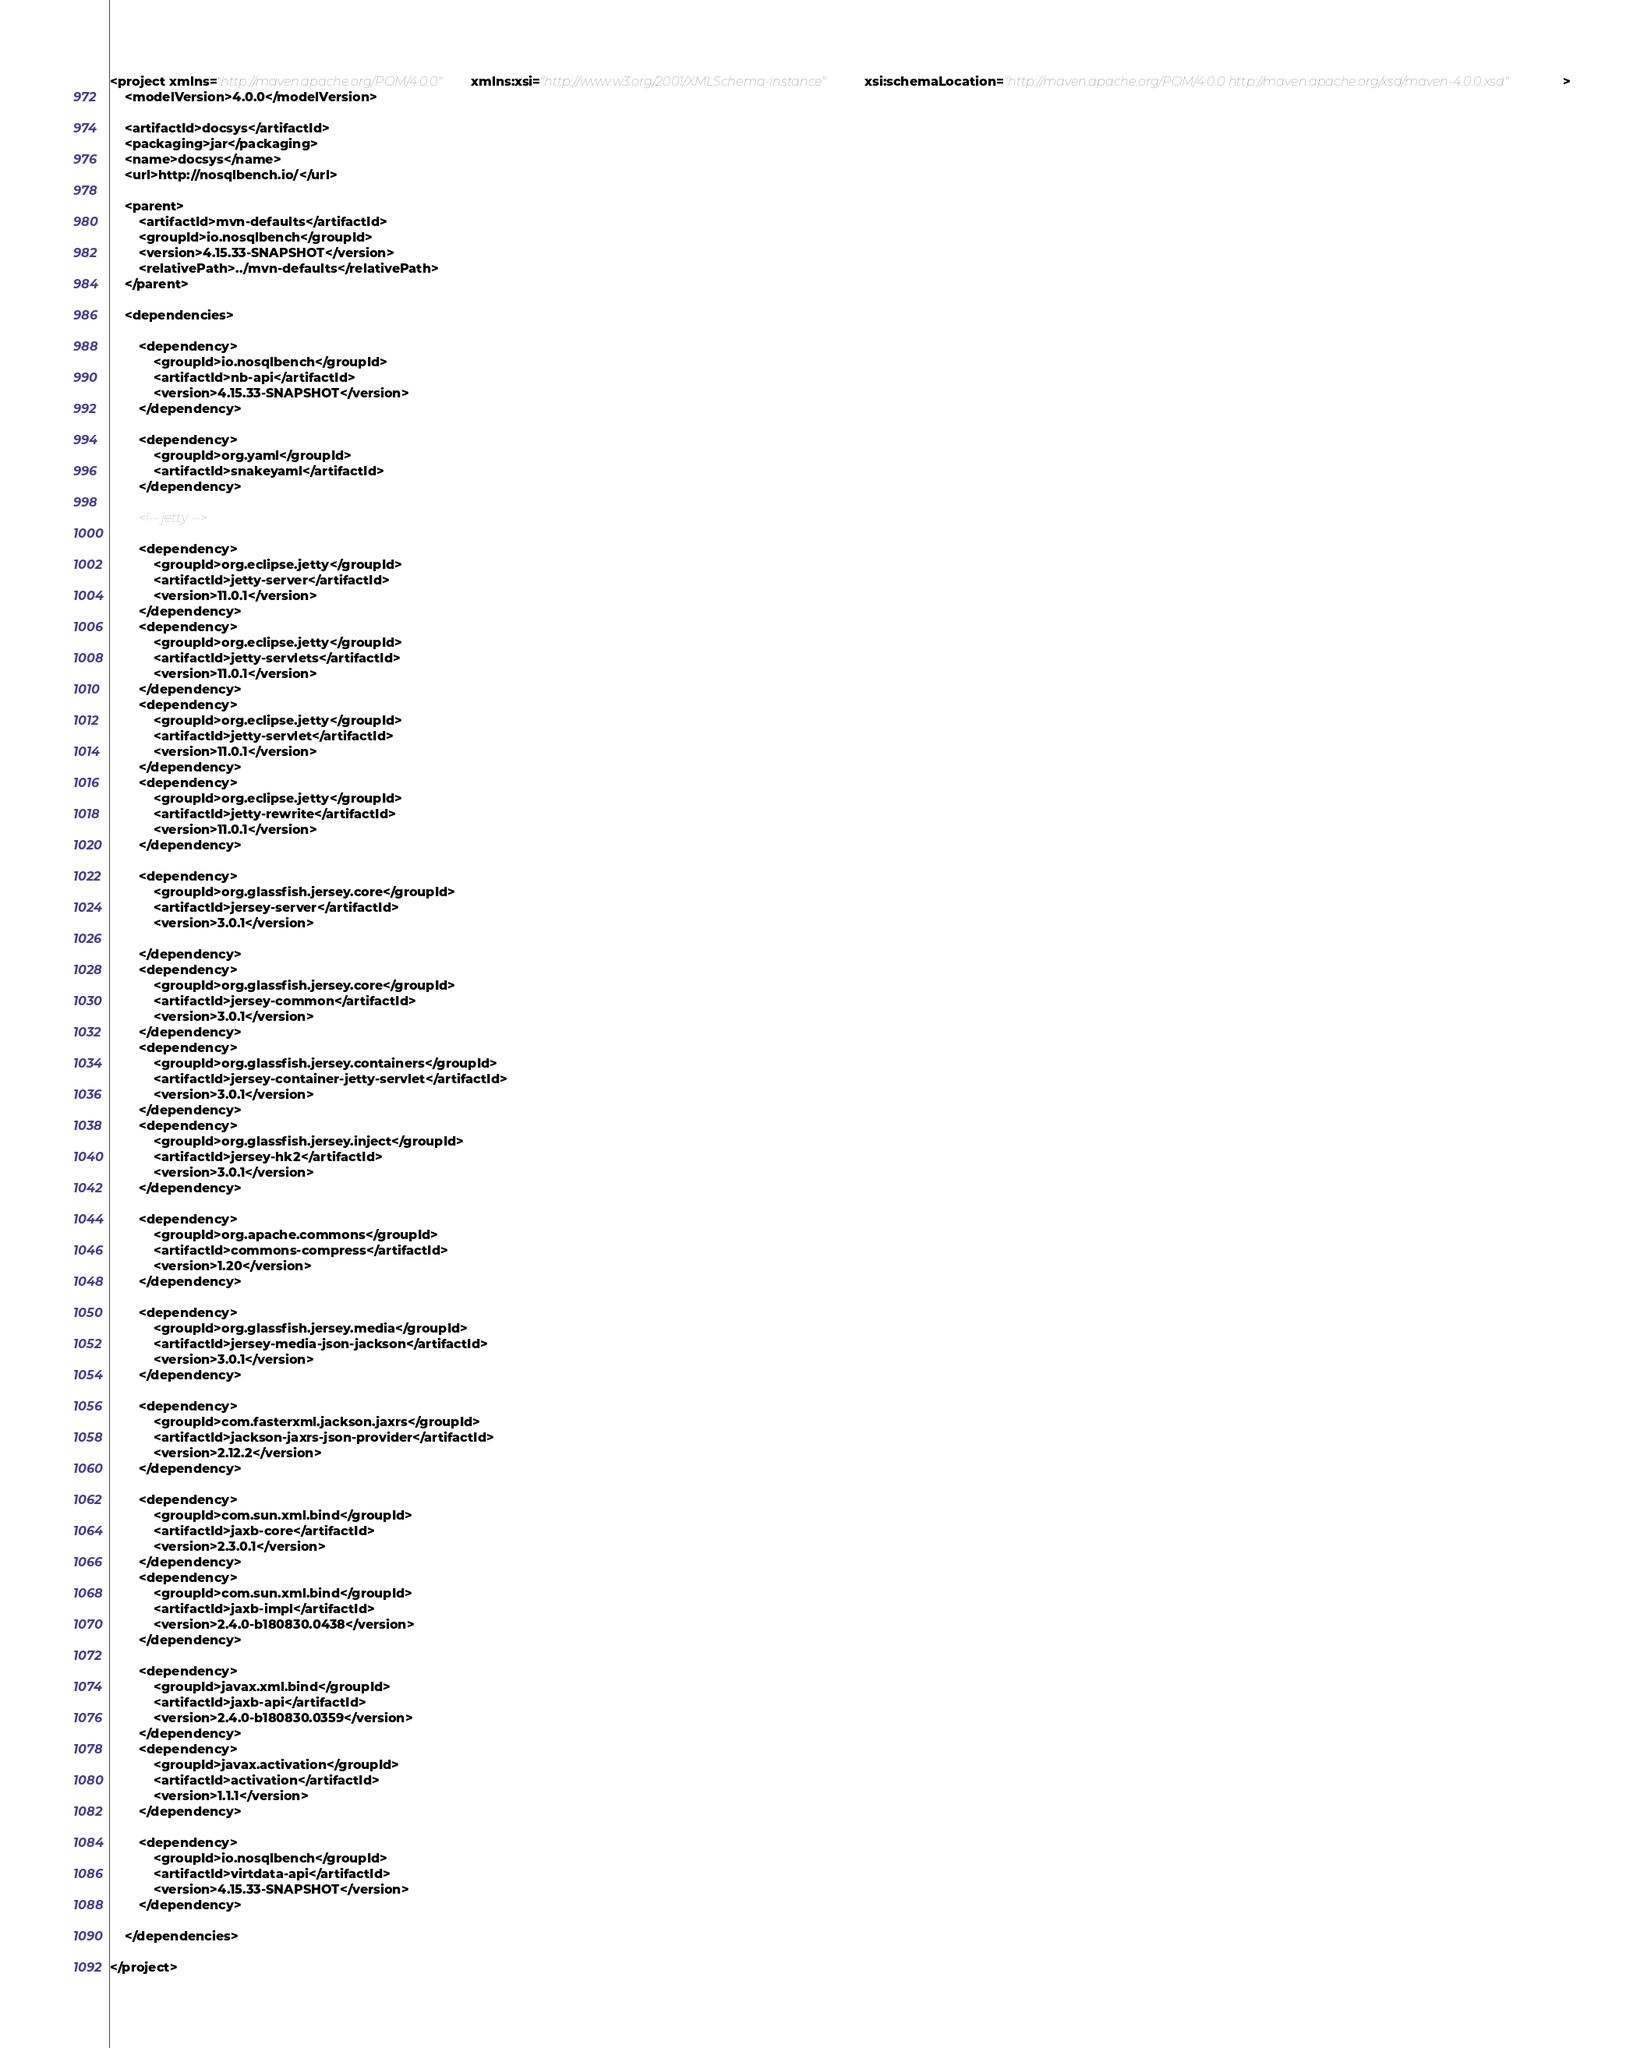Convert code to text. <code><loc_0><loc_0><loc_500><loc_500><_XML_><project xmlns="http://maven.apache.org/POM/4.0.0" xmlns:xsi="http://www.w3.org/2001/XMLSchema-instance" xsi:schemaLocation="http://maven.apache.org/POM/4.0.0 http://maven.apache.org/xsd/maven-4.0.0.xsd">
    <modelVersion>4.0.0</modelVersion>

    <artifactId>docsys</artifactId>
    <packaging>jar</packaging>
    <name>docsys</name>
    <url>http://nosqlbench.io/</url>

    <parent>
        <artifactId>mvn-defaults</artifactId>
        <groupId>io.nosqlbench</groupId>
        <version>4.15.33-SNAPSHOT</version>
        <relativePath>../mvn-defaults</relativePath>
    </parent>

    <dependencies>

        <dependency>
            <groupId>io.nosqlbench</groupId>
            <artifactId>nb-api</artifactId>
            <version>4.15.33-SNAPSHOT</version>
        </dependency>

        <dependency>
            <groupId>org.yaml</groupId>
            <artifactId>snakeyaml</artifactId>
        </dependency>

        <!-- jetty -->

        <dependency>
            <groupId>org.eclipse.jetty</groupId>
            <artifactId>jetty-server</artifactId>
            <version>11.0.1</version>
        </dependency>
        <dependency>
            <groupId>org.eclipse.jetty</groupId>
            <artifactId>jetty-servlets</artifactId>
            <version>11.0.1</version>
        </dependency>
        <dependency>
            <groupId>org.eclipse.jetty</groupId>
            <artifactId>jetty-servlet</artifactId>
            <version>11.0.1</version>
        </dependency>
        <dependency>
            <groupId>org.eclipse.jetty</groupId>
            <artifactId>jetty-rewrite</artifactId>
            <version>11.0.1</version>
        </dependency>

        <dependency>
            <groupId>org.glassfish.jersey.core</groupId>
            <artifactId>jersey-server</artifactId>
            <version>3.0.1</version>

        </dependency>
        <dependency>
            <groupId>org.glassfish.jersey.core</groupId>
            <artifactId>jersey-common</artifactId>
            <version>3.0.1</version>
        </dependency>
        <dependency>
            <groupId>org.glassfish.jersey.containers</groupId>
            <artifactId>jersey-container-jetty-servlet</artifactId>
            <version>3.0.1</version>
        </dependency>
        <dependency>
            <groupId>org.glassfish.jersey.inject</groupId>
            <artifactId>jersey-hk2</artifactId>
            <version>3.0.1</version>
        </dependency>

        <dependency>
            <groupId>org.apache.commons</groupId>
            <artifactId>commons-compress</artifactId>
            <version>1.20</version>
        </dependency>

        <dependency>
            <groupId>org.glassfish.jersey.media</groupId>
            <artifactId>jersey-media-json-jackson</artifactId>
            <version>3.0.1</version>
        </dependency>

        <dependency>
            <groupId>com.fasterxml.jackson.jaxrs</groupId>
            <artifactId>jackson-jaxrs-json-provider</artifactId>
            <version>2.12.2</version>
        </dependency>

        <dependency>
            <groupId>com.sun.xml.bind</groupId>
            <artifactId>jaxb-core</artifactId>
            <version>2.3.0.1</version>
        </dependency>
        <dependency>
            <groupId>com.sun.xml.bind</groupId>
            <artifactId>jaxb-impl</artifactId>
            <version>2.4.0-b180830.0438</version>
        </dependency>

        <dependency>
            <groupId>javax.xml.bind</groupId>
            <artifactId>jaxb-api</artifactId>
            <version>2.4.0-b180830.0359</version>
        </dependency>
        <dependency>
            <groupId>javax.activation</groupId>
            <artifactId>activation</artifactId>
            <version>1.1.1</version>
        </dependency>

        <dependency>
            <groupId>io.nosqlbench</groupId>
            <artifactId>virtdata-api</artifactId>
            <version>4.15.33-SNAPSHOT</version>
        </dependency>

    </dependencies>

</project>
</code> 